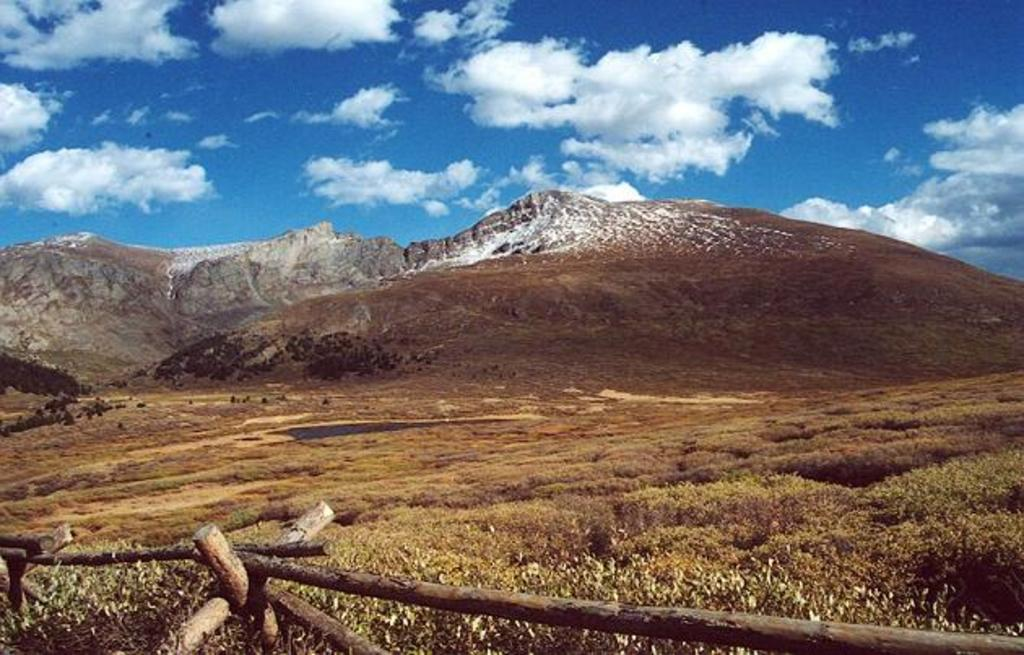What type of natural formation can be seen in the background of the image? There are mountains in the background of the image. What is visible at the top of the image? The sky and clouds are visible at the top of the image. What type of vegetation is present at the bottom of the image? Grass is present at the bottom of the image. What type of barrier can be seen in the image? There is a wooden fencing in the image. What type of cabbage is growing on the wooden fencing in the image? There is no cabbage present in the image; it features mountains, sky, clouds, grass, and a wooden fencing. How many tickets are visible in the image? There are no tickets present in the image. 